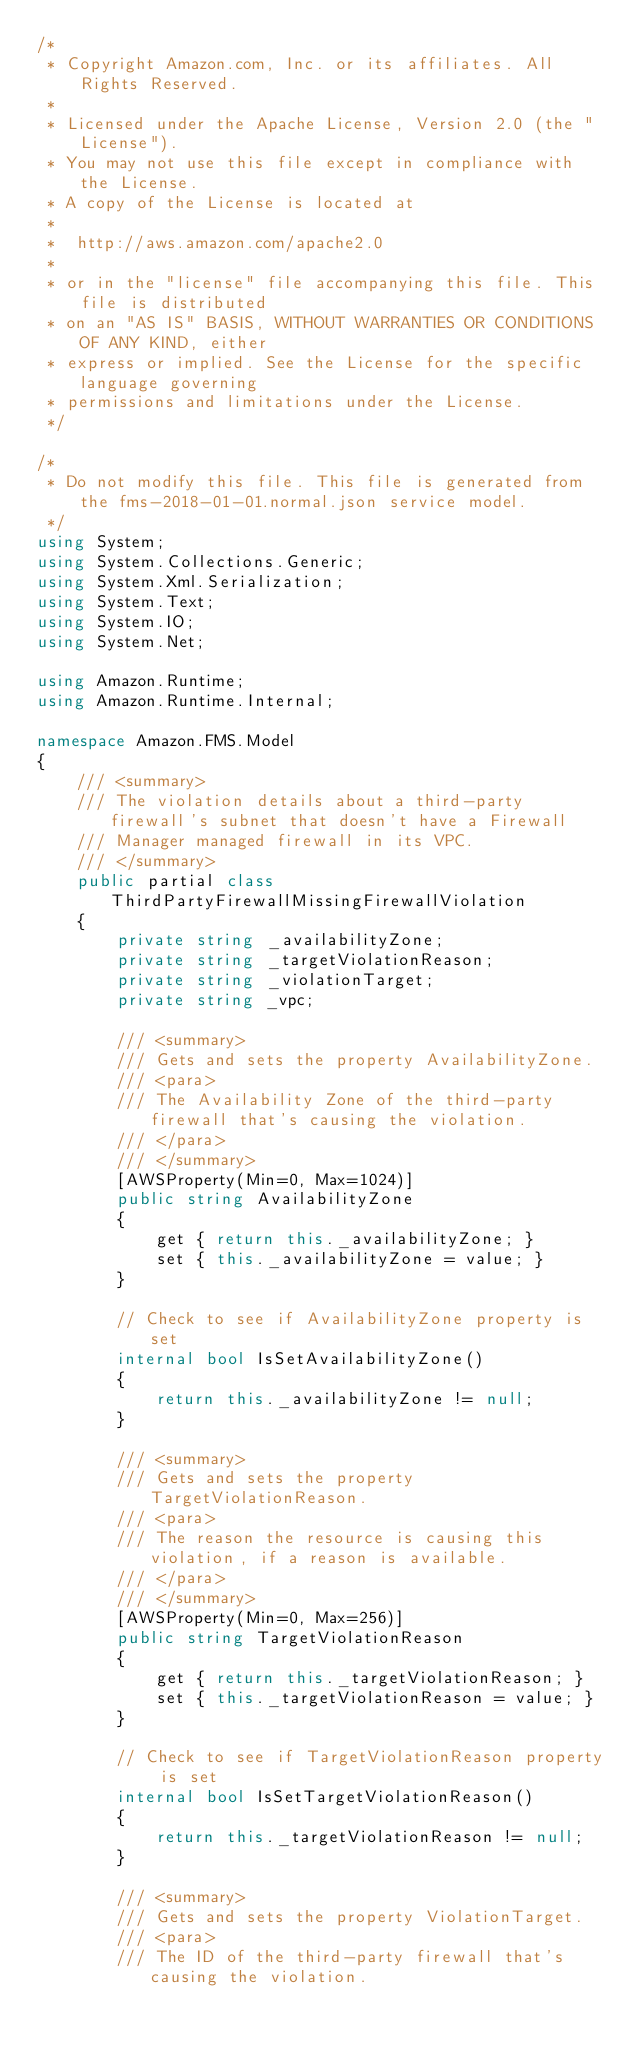<code> <loc_0><loc_0><loc_500><loc_500><_C#_>/*
 * Copyright Amazon.com, Inc. or its affiliates. All Rights Reserved.
 * 
 * Licensed under the Apache License, Version 2.0 (the "License").
 * You may not use this file except in compliance with the License.
 * A copy of the License is located at
 * 
 *  http://aws.amazon.com/apache2.0
 * 
 * or in the "license" file accompanying this file. This file is distributed
 * on an "AS IS" BASIS, WITHOUT WARRANTIES OR CONDITIONS OF ANY KIND, either
 * express or implied. See the License for the specific language governing
 * permissions and limitations under the License.
 */

/*
 * Do not modify this file. This file is generated from the fms-2018-01-01.normal.json service model.
 */
using System;
using System.Collections.Generic;
using System.Xml.Serialization;
using System.Text;
using System.IO;
using System.Net;

using Amazon.Runtime;
using Amazon.Runtime.Internal;

namespace Amazon.FMS.Model
{
    /// <summary>
    /// The violation details about a third-party firewall's subnet that doesn't have a Firewall
    /// Manager managed firewall in its VPC.
    /// </summary>
    public partial class ThirdPartyFirewallMissingFirewallViolation
    {
        private string _availabilityZone;
        private string _targetViolationReason;
        private string _violationTarget;
        private string _vpc;

        /// <summary>
        /// Gets and sets the property AvailabilityZone. 
        /// <para>
        /// The Availability Zone of the third-party firewall that's causing the violation.
        /// </para>
        /// </summary>
        [AWSProperty(Min=0, Max=1024)]
        public string AvailabilityZone
        {
            get { return this._availabilityZone; }
            set { this._availabilityZone = value; }
        }

        // Check to see if AvailabilityZone property is set
        internal bool IsSetAvailabilityZone()
        {
            return this._availabilityZone != null;
        }

        /// <summary>
        /// Gets and sets the property TargetViolationReason. 
        /// <para>
        /// The reason the resource is causing this violation, if a reason is available.
        /// </para>
        /// </summary>
        [AWSProperty(Min=0, Max=256)]
        public string TargetViolationReason
        {
            get { return this._targetViolationReason; }
            set { this._targetViolationReason = value; }
        }

        // Check to see if TargetViolationReason property is set
        internal bool IsSetTargetViolationReason()
        {
            return this._targetViolationReason != null;
        }

        /// <summary>
        /// Gets and sets the property ViolationTarget. 
        /// <para>
        /// The ID of the third-party firewall that's causing the violation.</code> 